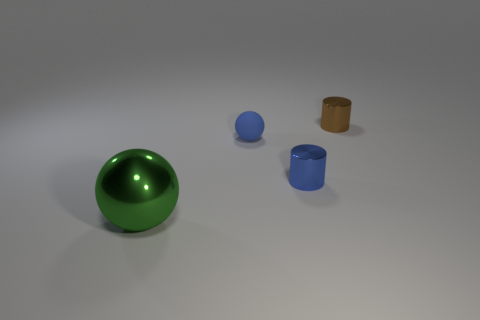Add 4 tiny blue balls. How many objects exist? 8 Subtract all yellow metallic blocks. Subtract all tiny cylinders. How many objects are left? 2 Add 3 green metallic balls. How many green metallic balls are left? 4 Add 2 gray cylinders. How many gray cylinders exist? 2 Subtract 0 yellow balls. How many objects are left? 4 